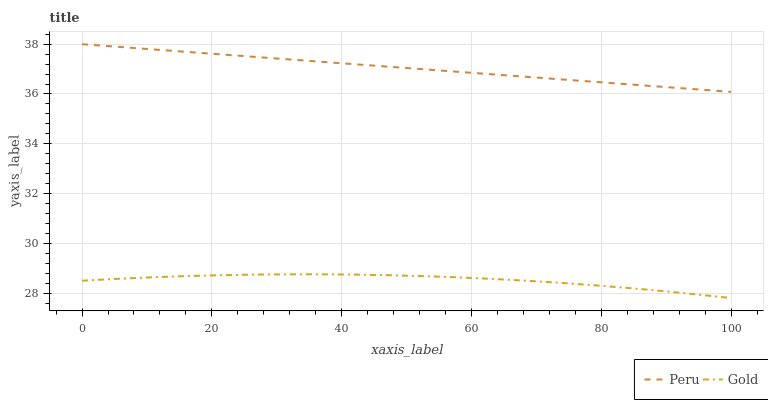Does Gold have the minimum area under the curve?
Answer yes or no. Yes. Does Peru have the maximum area under the curve?
Answer yes or no. Yes. Does Peru have the minimum area under the curve?
Answer yes or no. No. Is Peru the smoothest?
Answer yes or no. Yes. Is Gold the roughest?
Answer yes or no. Yes. Is Peru the roughest?
Answer yes or no. No. Does Gold have the lowest value?
Answer yes or no. Yes. Does Peru have the lowest value?
Answer yes or no. No. Does Peru have the highest value?
Answer yes or no. Yes. Is Gold less than Peru?
Answer yes or no. Yes. Is Peru greater than Gold?
Answer yes or no. Yes. Does Gold intersect Peru?
Answer yes or no. No. 